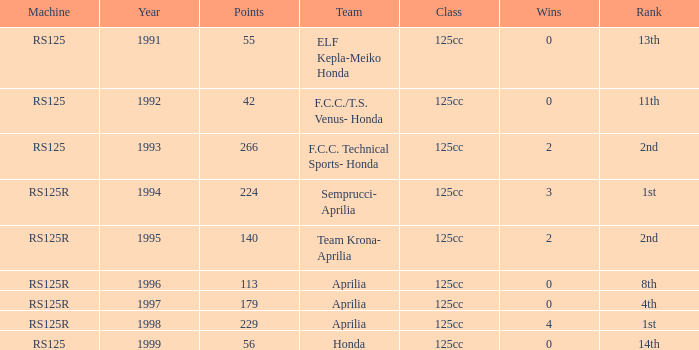What year featured an aprilia team with a 4th place standing? 1997.0. 